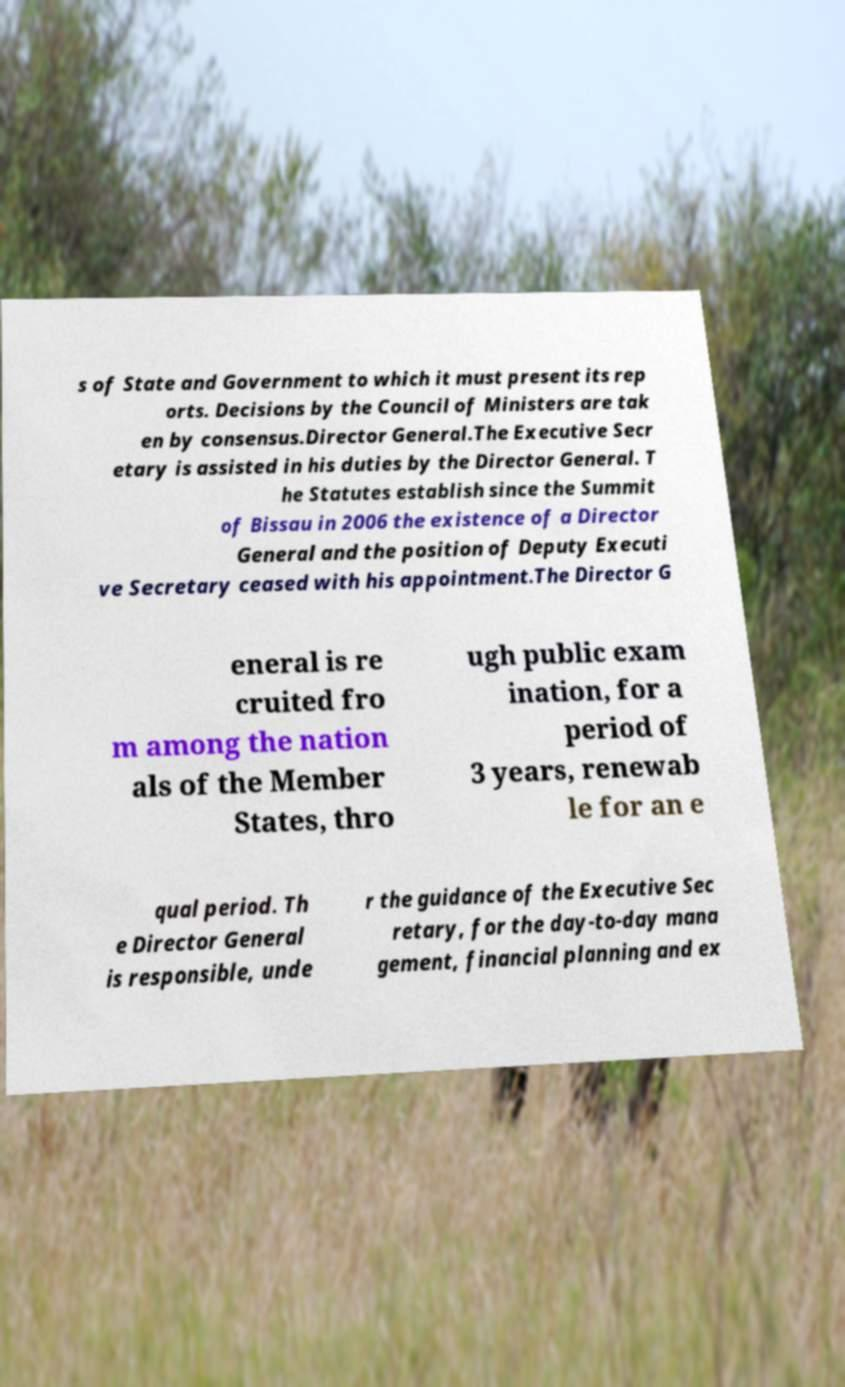Please read and relay the text visible in this image. What does it say? s of State and Government to which it must present its rep orts. Decisions by the Council of Ministers are tak en by consensus.Director General.The Executive Secr etary is assisted in his duties by the Director General. T he Statutes establish since the Summit of Bissau in 2006 the existence of a Director General and the position of Deputy Executi ve Secretary ceased with his appointment.The Director G eneral is re cruited fro m among the nation als of the Member States, thro ugh public exam ination, for a period of 3 years, renewab le for an e qual period. Th e Director General is responsible, unde r the guidance of the Executive Sec retary, for the day-to-day mana gement, financial planning and ex 